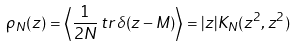Convert formula to latex. <formula><loc_0><loc_0><loc_500><loc_500>\rho _ { N } ( z ) = \left \langle \frac { 1 } { 2 N } \, t r \, \delta ( z - M ) \right \rangle = | z | K _ { N } ( z ^ { 2 } , z ^ { 2 } )</formula> 